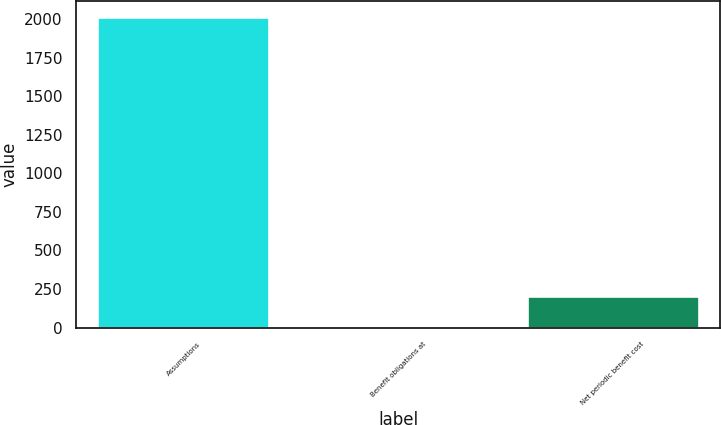<chart> <loc_0><loc_0><loc_500><loc_500><bar_chart><fcel>Assumptions<fcel>Benefit obligations at<fcel>Net periodic benefit cost<nl><fcel>2015<fcel>3.5<fcel>204.65<nl></chart> 